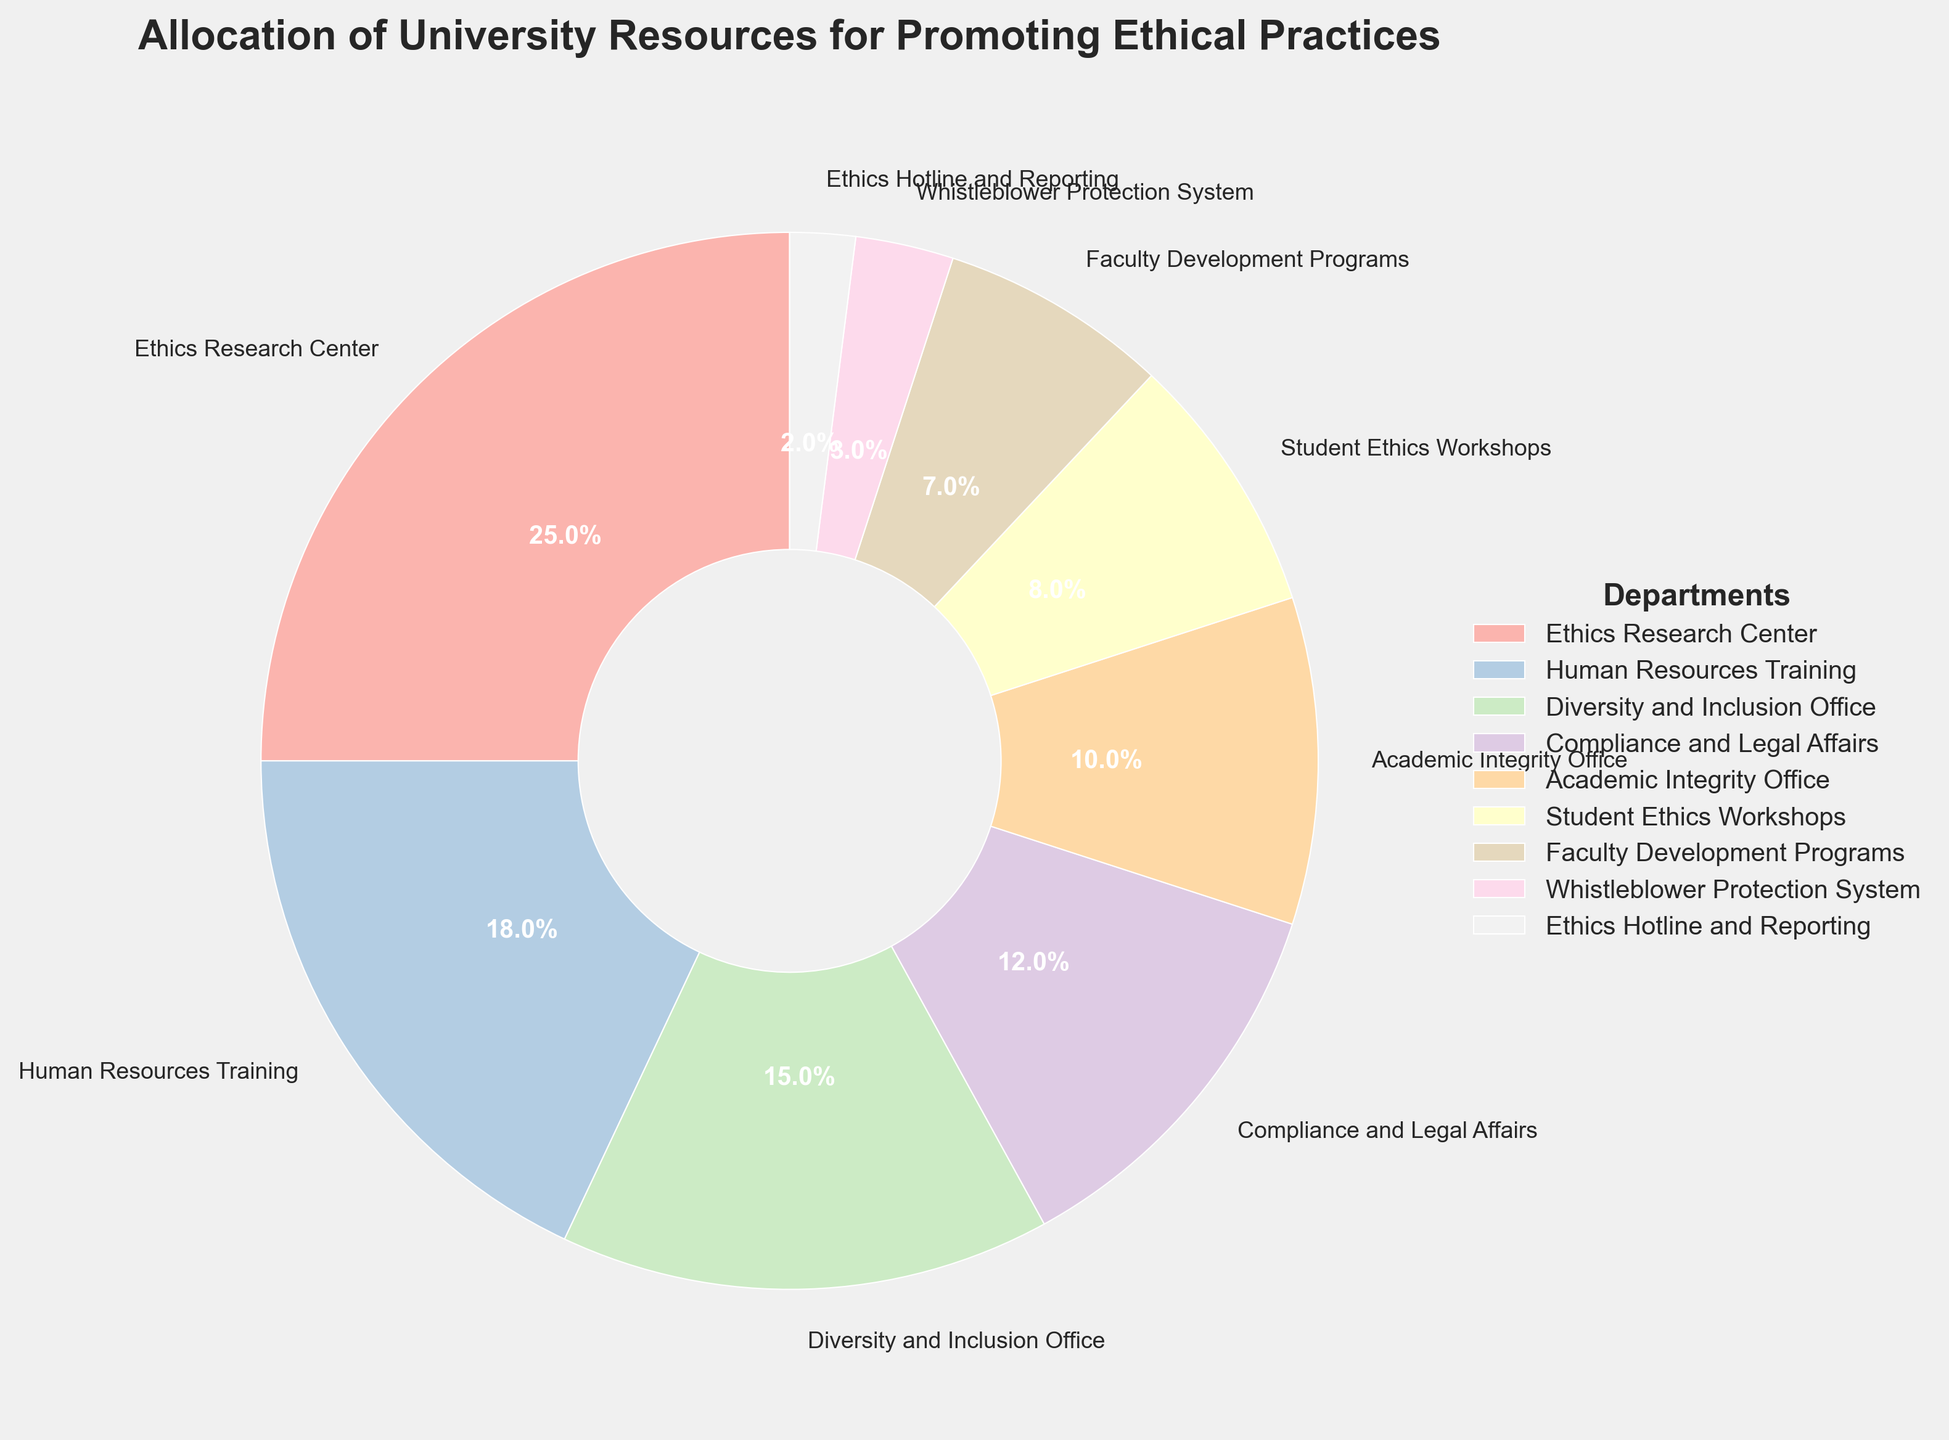What is the largest budget allocation? The largest wedge in the pie chart represents the department "Ethics Research Center" with 25%.
Answer: 25% Which department has a budget allocation closest to 10%? The "Academic Integrity Office" is labeled with a 10% allocation.
Answer: Academic Integrity Office How much more budget is allocated to the "Ethics Research Center" compared to the "Student Ethics Workshops"? The "Ethics Research Center" has 25%, and "Student Ethics Workshops" has 8%. Subtracting these gives 25% - 8% = 17%.
Answer: 17% Which two departments combined have exactly 20% of the budget allocation? Adding "Whistleblower Protection System" (3%) and "Student Ethics Workshops" (8%) gives 3% + 8% = 11%. Adding "Faculty Development Programs" (7%) to "Student Ethics Workshops" (8%) gives 7% + 8% = 15%. Adding "Compliance and Legal Affairs" (12%) to "Ethics Hotline and Reporting" (2%) gives 12% + 2% = 14%. Adding "Academic Integrity Office" (10%) to "Student Ethics Workshops" (8%) gives 10% + 8% = 18%. Adding "Whistleblower Protection System" (3%) to "Ethics Hotline and Reporting" (2%) gives 3% + 2% = 5%. Adding "Whistleblower Protection System" (3%) to "Faculty Development Programs" (7%) gives 3% + 7% = 10%.
Answer: None Is the budget allocation for "Diversity and Inclusion Office" greater than that for "Compliance and Legal Affairs"? "Diversity and Inclusion Office" has 15%, and "Compliance and Legal Affairs" has 12%. Therefore, 15% > 12%.
Answer: Yes Which department has the smallest budget allocation? The smallest wedge in the pie chart represents "Ethics Hotline and Reporting" with 2%.
Answer: Ethics Hotline and Reporting How much percentage is allocated in total to the "Diversity and Inclusion Office", "Compliance and Legal Affairs", and "Academic Integrity Office" combined? The allocations are 15%, 12%, and 10%, respectively. Adding these gives 15% + 12% + 10% = 37%.
Answer: 37% How does the budget for "Human Resources Training" compare to that of "Ethics Research Center"? "Human Resources Training" has an 18% allocation, while "Ethics Research Center" has 25%. 18% < 25%.
Answer: Less What percentage of the total budget is allocated to departments with less than 5% each? The departments are "Whistleblower Protection System" (3%) and "Ethics Hotline and Reporting" (2%). Adding these gives 3% + 2% = 5%.
Answer: 5% Which department's allocation is represented using a pastel shade color? All departments are, as the pie chart employs pastel shades throughout for variety.
Answer: All departments 